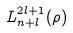<formula> <loc_0><loc_0><loc_500><loc_500>L _ { n + l } ^ { 2 l + 1 } ( \rho )</formula> 